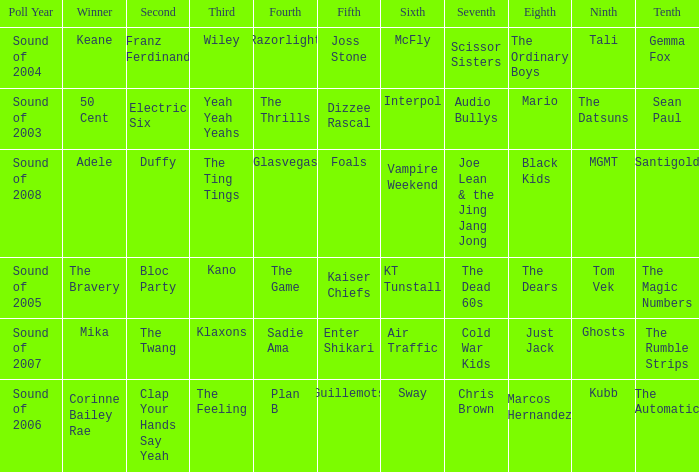When dizzee rascal is 5th, who was the winner? 50 Cent. 